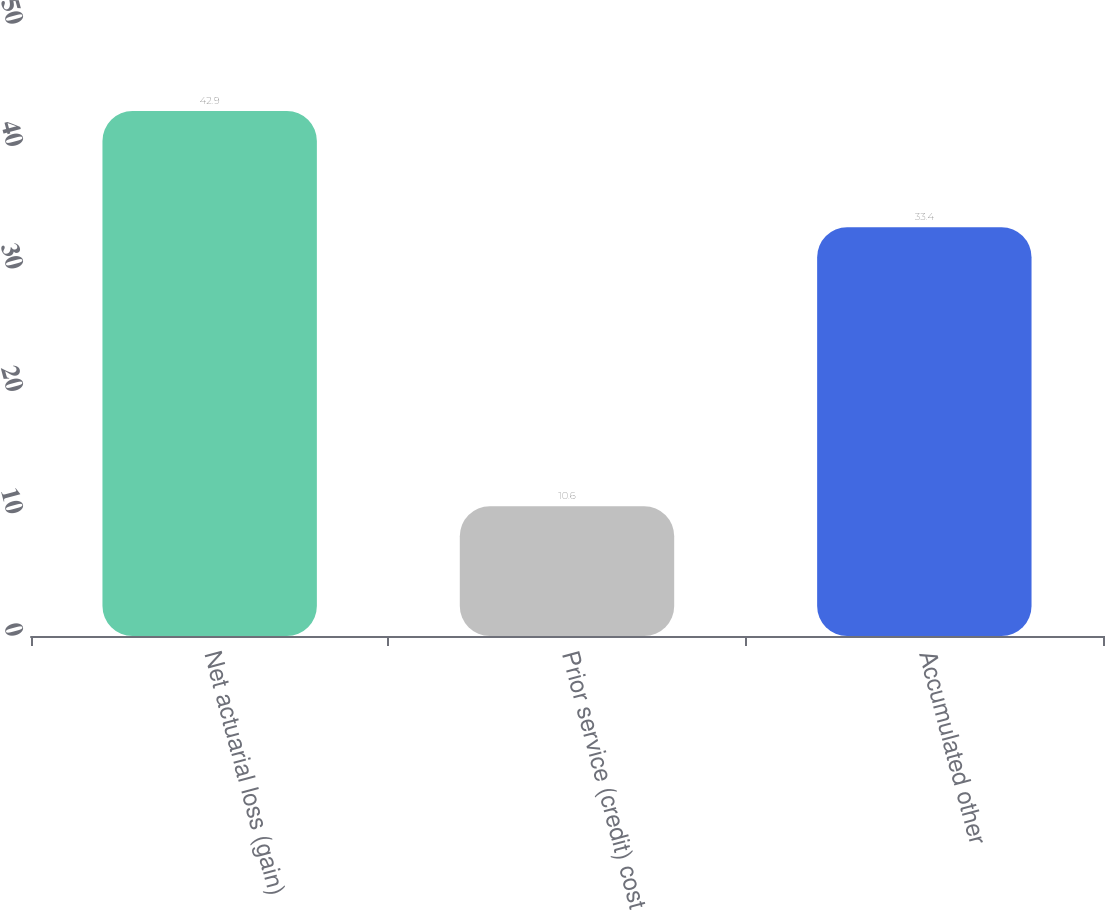Convert chart. <chart><loc_0><loc_0><loc_500><loc_500><bar_chart><fcel>Net actuarial loss (gain)<fcel>Prior service (credit) cost<fcel>Accumulated other<nl><fcel>42.9<fcel>10.6<fcel>33.4<nl></chart> 